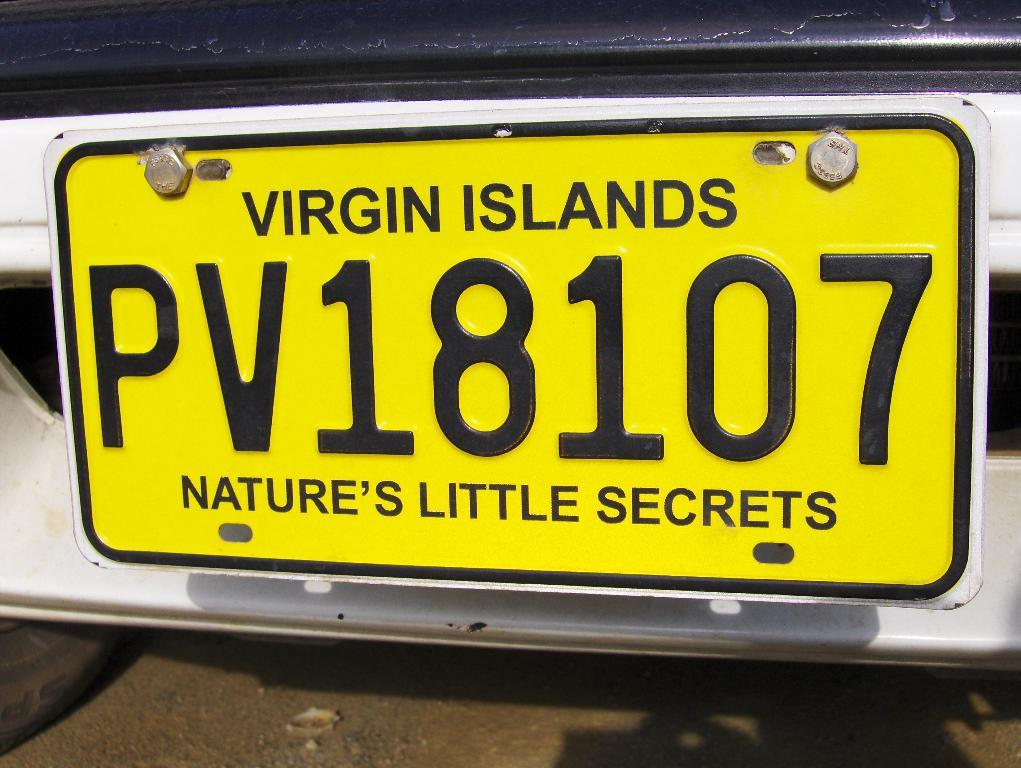<image>
Provide a brief description of the given image. Virgin Islands License Plate that says PV18107 Nature's Little Secrets. 